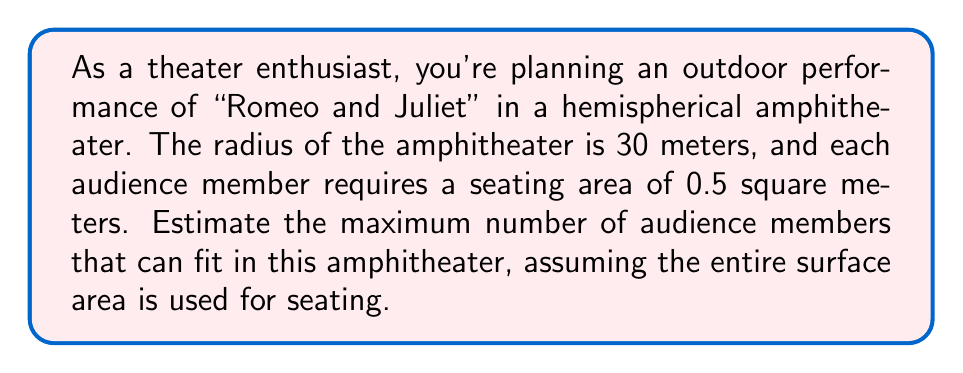Solve this math problem. Let's approach this step-by-step:

1) The amphitheater is a hemisphere, so we need to calculate its surface area.

2) The formula for the surface area of a hemisphere is:
   $$A = 2\pi r^2$$
   Where $r$ is the radius.

3) Given radius $r = 30$ meters, let's calculate the surface area:
   $$A = 2\pi (30)^2 = 2\pi (900) = 1800\pi \approx 5655.29\text{ m}^2$$

4) However, we need to account for the flat circular base, which isn't used for seating. The area of this circle is:
   $$A_{\text{circle}} = \pi r^2 = \pi (30)^2 = 900\pi \approx 2827.43\text{ m}^2$$

5) So the actual seating area is:
   $$A_{\text{seating}} = 5655.29 - 2827.43 = 2827.86\text{ m}^2$$

6) Each audience member requires 0.5 square meters. To find the number of audience members, we divide the seating area by the area per person:
   $$\text{Number of audience} = \frac{2827.86\text{ m}^2}{0.5\text{ m}^2/\text{person}} = 5655.72\text{ people}$$

7) Since we can't have a fractional person, we round down to get the maximum whole number of people.

[asy]
import geometry;

size(200);
pair O=(0,0);
real r=5;
draw(arc(O,r,0,180));
draw((-r,0)--(r,0),dashed);
label("30m",(-r/2,r/2),NW);
[/asy]
Answer: 5655 people 